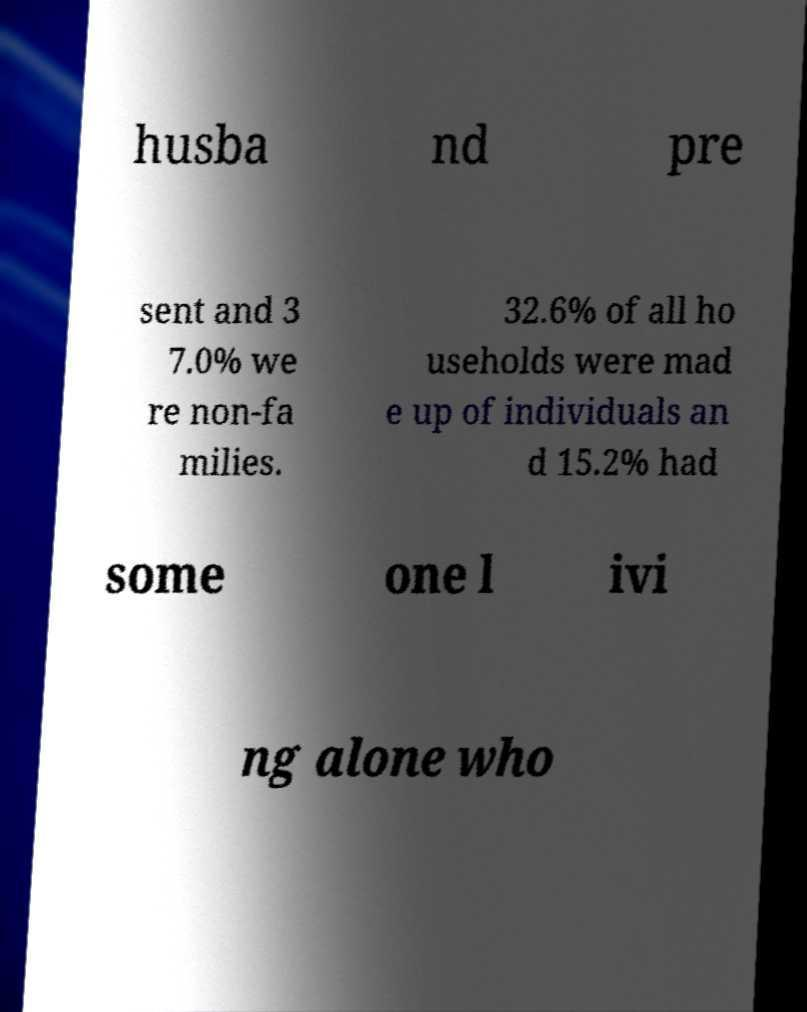Can you read and provide the text displayed in the image?This photo seems to have some interesting text. Can you extract and type it out for me? husba nd pre sent and 3 7.0% we re non-fa milies. 32.6% of all ho useholds were mad e up of individuals an d 15.2% had some one l ivi ng alone who 